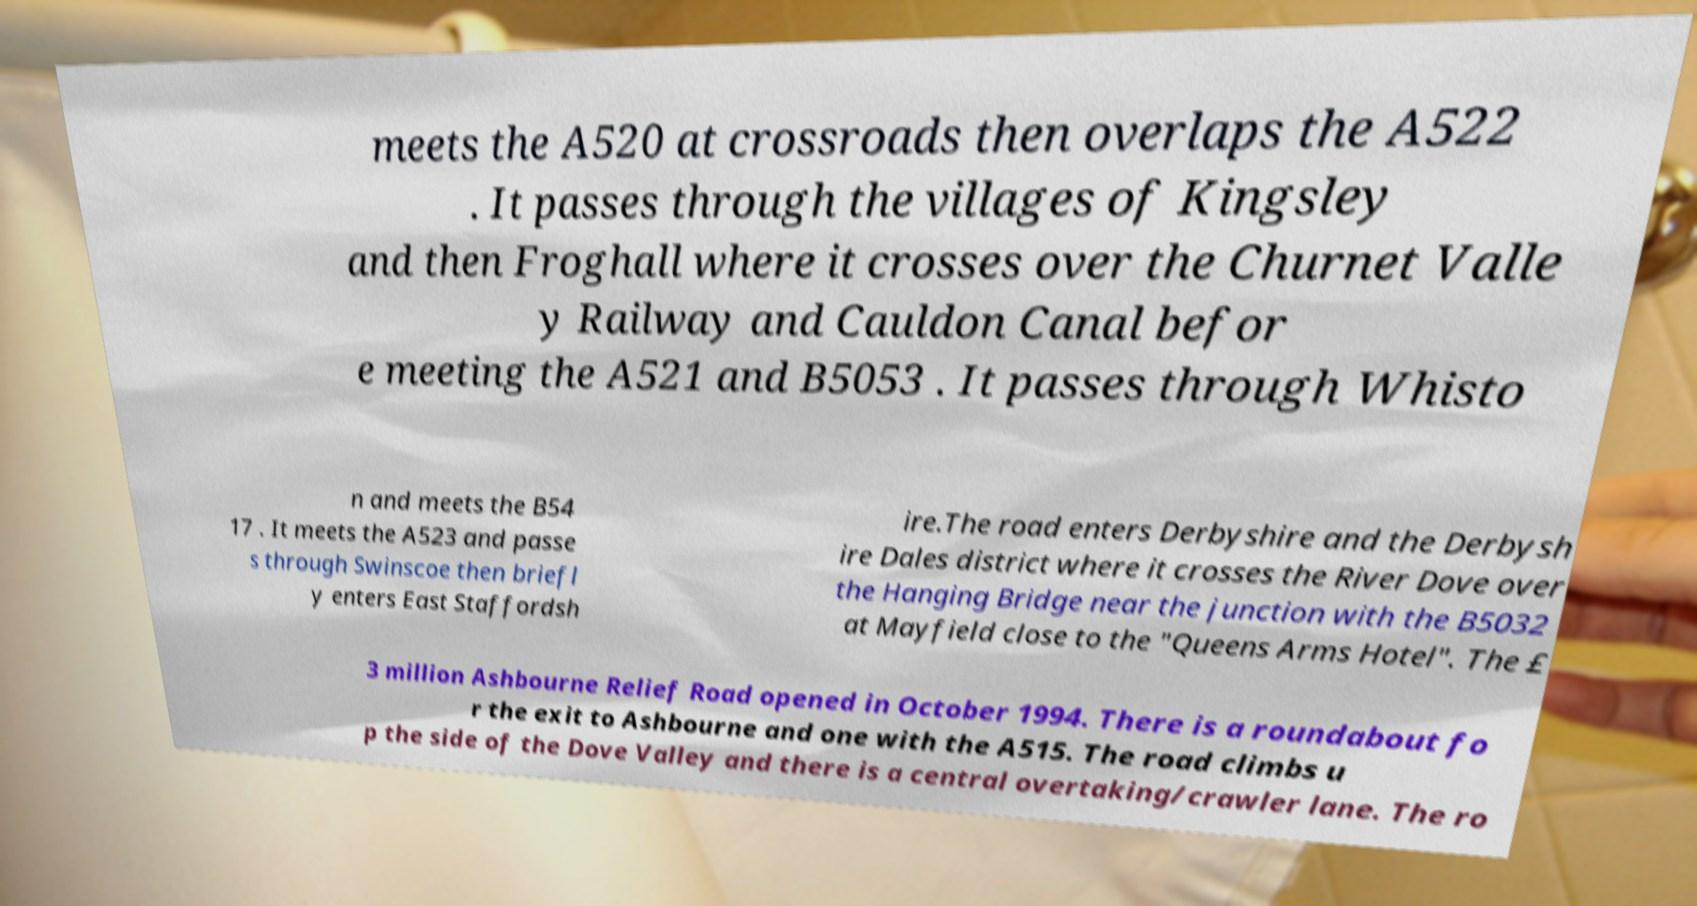For documentation purposes, I need the text within this image transcribed. Could you provide that? meets the A520 at crossroads then overlaps the A522 . It passes through the villages of Kingsley and then Froghall where it crosses over the Churnet Valle y Railway and Cauldon Canal befor e meeting the A521 and B5053 . It passes through Whisto n and meets the B54 17 . It meets the A523 and passe s through Swinscoe then briefl y enters East Staffordsh ire.The road enters Derbyshire and the Derbysh ire Dales district where it crosses the River Dove over the Hanging Bridge near the junction with the B5032 at Mayfield close to the "Queens Arms Hotel". The £ 3 million Ashbourne Relief Road opened in October 1994. There is a roundabout fo r the exit to Ashbourne and one with the A515. The road climbs u p the side of the Dove Valley and there is a central overtaking/crawler lane. The ro 